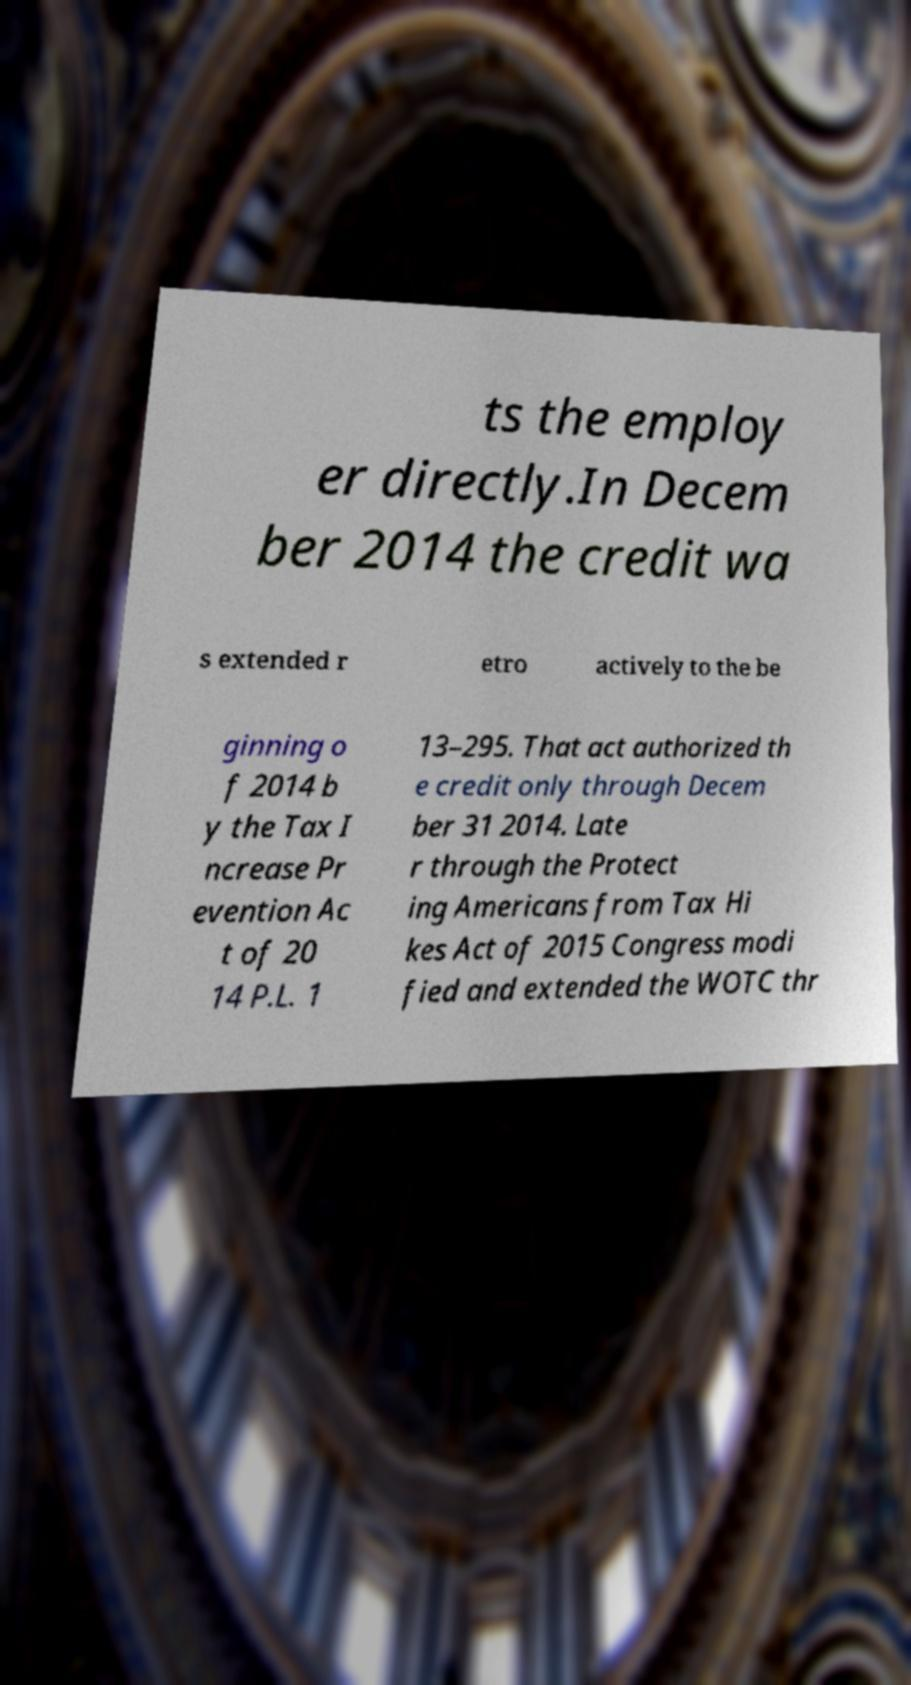There's text embedded in this image that I need extracted. Can you transcribe it verbatim? ts the employ er directly.In Decem ber 2014 the credit wa s extended r etro actively to the be ginning o f 2014 b y the Tax I ncrease Pr evention Ac t of 20 14 P.L. 1 13–295. That act authorized th e credit only through Decem ber 31 2014. Late r through the Protect ing Americans from Tax Hi kes Act of 2015 Congress modi fied and extended the WOTC thr 